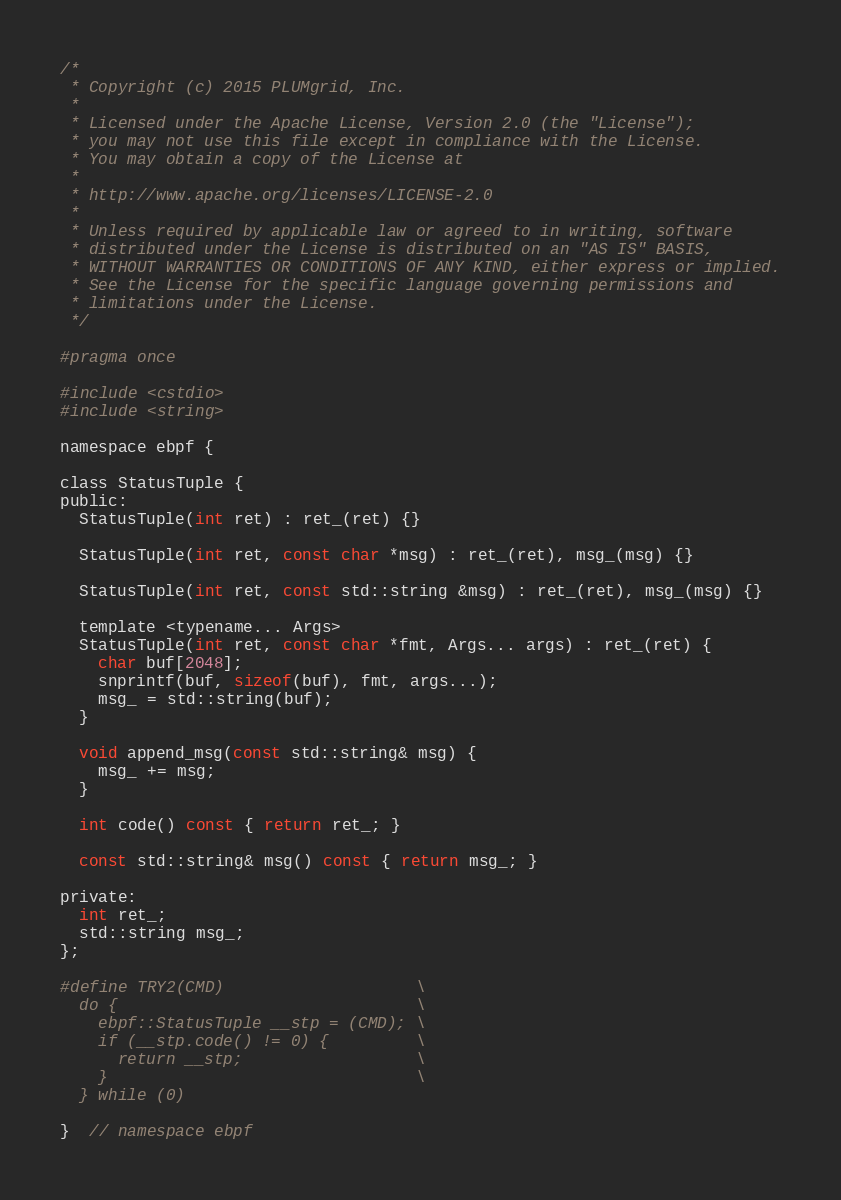Convert code to text. <code><loc_0><loc_0><loc_500><loc_500><_C_>/*
 * Copyright (c) 2015 PLUMgrid, Inc.
 *
 * Licensed under the Apache License, Version 2.0 (the "License");
 * you may not use this file except in compliance with the License.
 * You may obtain a copy of the License at
 *
 * http://www.apache.org/licenses/LICENSE-2.0
 *
 * Unless required by applicable law or agreed to in writing, software
 * distributed under the License is distributed on an "AS IS" BASIS,
 * WITHOUT WARRANTIES OR CONDITIONS OF ANY KIND, either express or implied.
 * See the License for the specific language governing permissions and
 * limitations under the License.
 */

#pragma once

#include <cstdio>
#include <string>

namespace ebpf {

class StatusTuple {
public:
  StatusTuple(int ret) : ret_(ret) {}

  StatusTuple(int ret, const char *msg) : ret_(ret), msg_(msg) {}

  StatusTuple(int ret, const std::string &msg) : ret_(ret), msg_(msg) {}

  template <typename... Args>
  StatusTuple(int ret, const char *fmt, Args... args) : ret_(ret) {
    char buf[2048];
    snprintf(buf, sizeof(buf), fmt, args...);
    msg_ = std::string(buf);
  }

  void append_msg(const std::string& msg) {
    msg_ += msg;
  }

  int code() const { return ret_; }

  const std::string& msg() const { return msg_; }

private:
  int ret_;
  std::string msg_;
};

#define TRY2(CMD)                    \
  do {                               \
    ebpf::StatusTuple __stp = (CMD); \
    if (__stp.code() != 0) {         \
      return __stp;                  \
    }                                \
  } while (0)

}  // namespace ebpf
</code> 